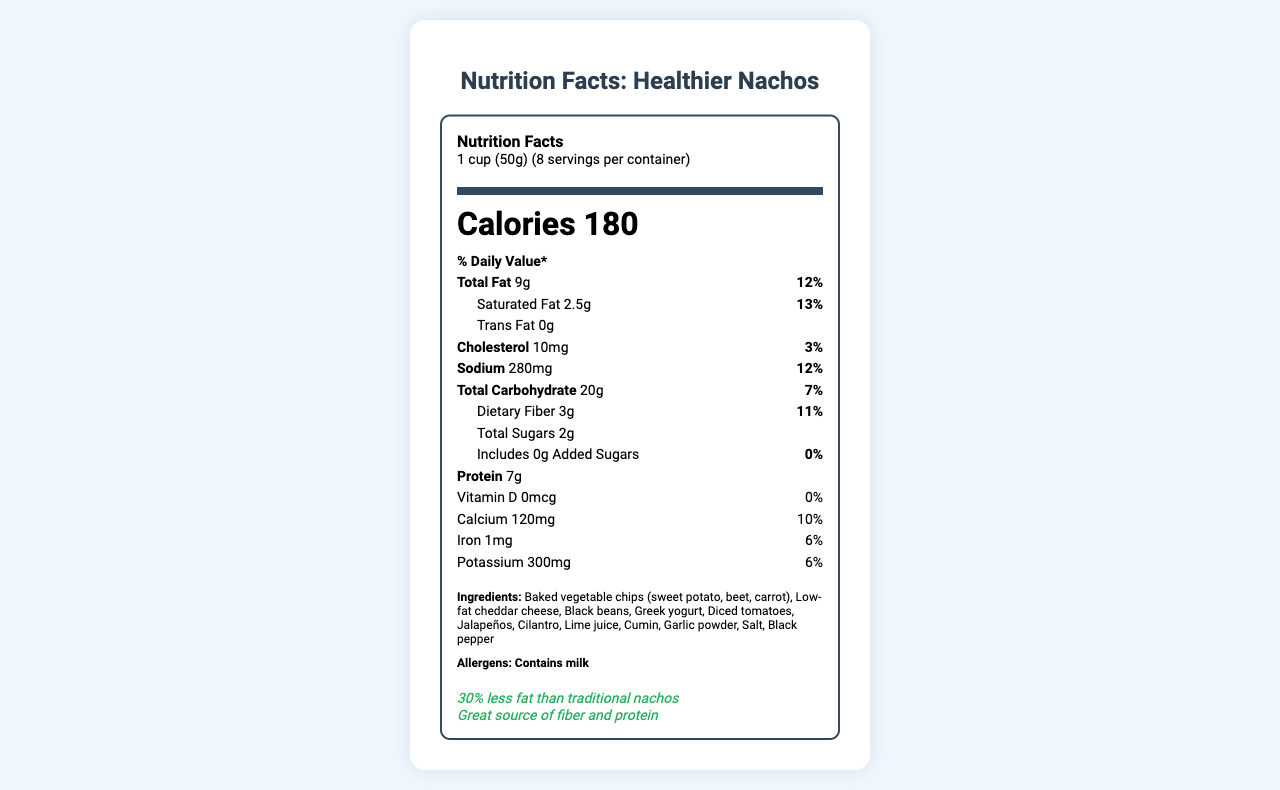what is the serving size? The serving size is mentioned at the beginning of the document as "1 cup (50g)".
Answer: 1 cup (50g) how many calories per serving? The number of calories per serving is listed as 180 in the document.
Answer: 180 what percentage of daily value is Total Fat? The % Daily Value for Total Fat is given as 12%.
Answer: 12% how many grams of protein are in each serving? The amount of protein per serving is listed as 7g.
Answer: 7g What is the amount of dietary fiber per serving? The dietary fiber per serving is mentioned as 3g.
Answer: 3g Does the product contain trans fat? The document states that Trans Fat is 0g.
Answer: No which ingredient in the nachos provides calcium? A. Black beans B. Low-fat cheddar cheese C. Greek yogurt D. Diced tomatoes Low-fat cheddar cheese is most likely to provide calcium, as it is listed among the ingredients and is a dairy product.
Answer: B. Low-fat cheddar cheese what is the daily value percentage of saturated fat? A. 10% B. 12% C. 13% D. 15% The % Daily Value for Saturated Fat is listed as 13%.
Answer: C. 13% is there any cholesterol in the product? The document indicates there is 10mg of cholesterol per serving.
Answer: Yes summarize the nutritional value of the healthier nachos The summarized nutritional value provides a complete nutritional breakdown per serving, the ingredients, allergens, and additional info such as reduced fat claim and dietary benefits.
Answer: The healthier nachos have 180 calories per serving (1 cup, 50g), with 9g of total fat (12% daily value), 2.5g of saturated fat (13% daily value), 0g trans fat, 10mg of cholesterol (3% daily value), 280mg of sodium (12% daily value), 20g of total carbohydrates (7% daily value), 3g of dietary fiber (11% daily value), 2g of total sugars, 0g added sugars, 7g of protein, 0mcg of vitamin D (0% daily value), 120mg of calcium (10% daily value), 1mg of iron (6% daily value), and 300mg of potassium (6% daily value). Ingredients include baked vegetable chips, low-fat cheddar cheese, black beans, Greek yogurt, and various vegetables and spices. The product is noted for containing milk allergens and presents a 30% reduction in fat compared to traditional nachos. does this product contain added sugars? The document states that added sugars are 0g.
Answer: No how many servings are in a container? The document states there are 8 servings per container.
Answer: 8 what allergens are present? The allergens listed in the document include milk.
Answer: Milk is this product baked or fried? The preparation method is mentioned as baked.
Answer: Baked list three ingredients in the healthier nachos These ingredients are listed among the components of the nachos.
Answer: Baked vegetable chips (sweet potato, beet, carrot), low-fat cheddar cheese, black beans how much vitamin D is in this product? The amount of vitamin D per serving is listed as 0mcg.
Answer: 0mcg what is the main nutritional benefit highlighted for these nachos? The document highlights that the nachos are a great source of fiber and protein.
Answer: Great source of fiber and protein what is the percentage of daily value for calcium? A. 5% B. 8% C. 10% D. 12% The daily value percentage for calcium is given as 10%.
Answer: C. 10% how much sodium does each serving have? The sodium content per serving is listed as 280mg.
Answer: 280mg what is the healthiest claim made about the nachos? The document claims that these nachos have 30% less fat compared to traditional nachos.
Answer: 30% less fat than traditional nachos what is the recipe for the vegetable chips? The document doesn't provide specific information on the recipe for the vegetable chips.
Answer: Cannot be determined 